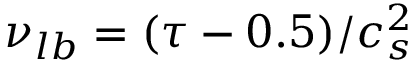<formula> <loc_0><loc_0><loc_500><loc_500>\nu _ { l b } = ( \tau - 0 . 5 ) / c _ { s } ^ { 2 }</formula> 